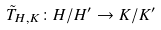Convert formula to latex. <formula><loc_0><loc_0><loc_500><loc_500>\tilde { T } _ { H , K } \colon H / H ^ { \prime } \rightarrow K / K ^ { \prime }</formula> 